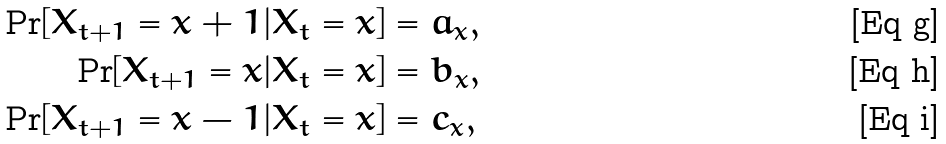<formula> <loc_0><loc_0><loc_500><loc_500>\Pr [ X _ { t + 1 } = x + 1 | X _ { t } = x ] & = a _ { x } , \\ \Pr [ X _ { t + 1 } = x | X _ { t } = x ] & = b _ { x } , \\ \Pr [ X _ { t + 1 } = x - 1 | X _ { t } = x ] & = c _ { x } ,</formula> 